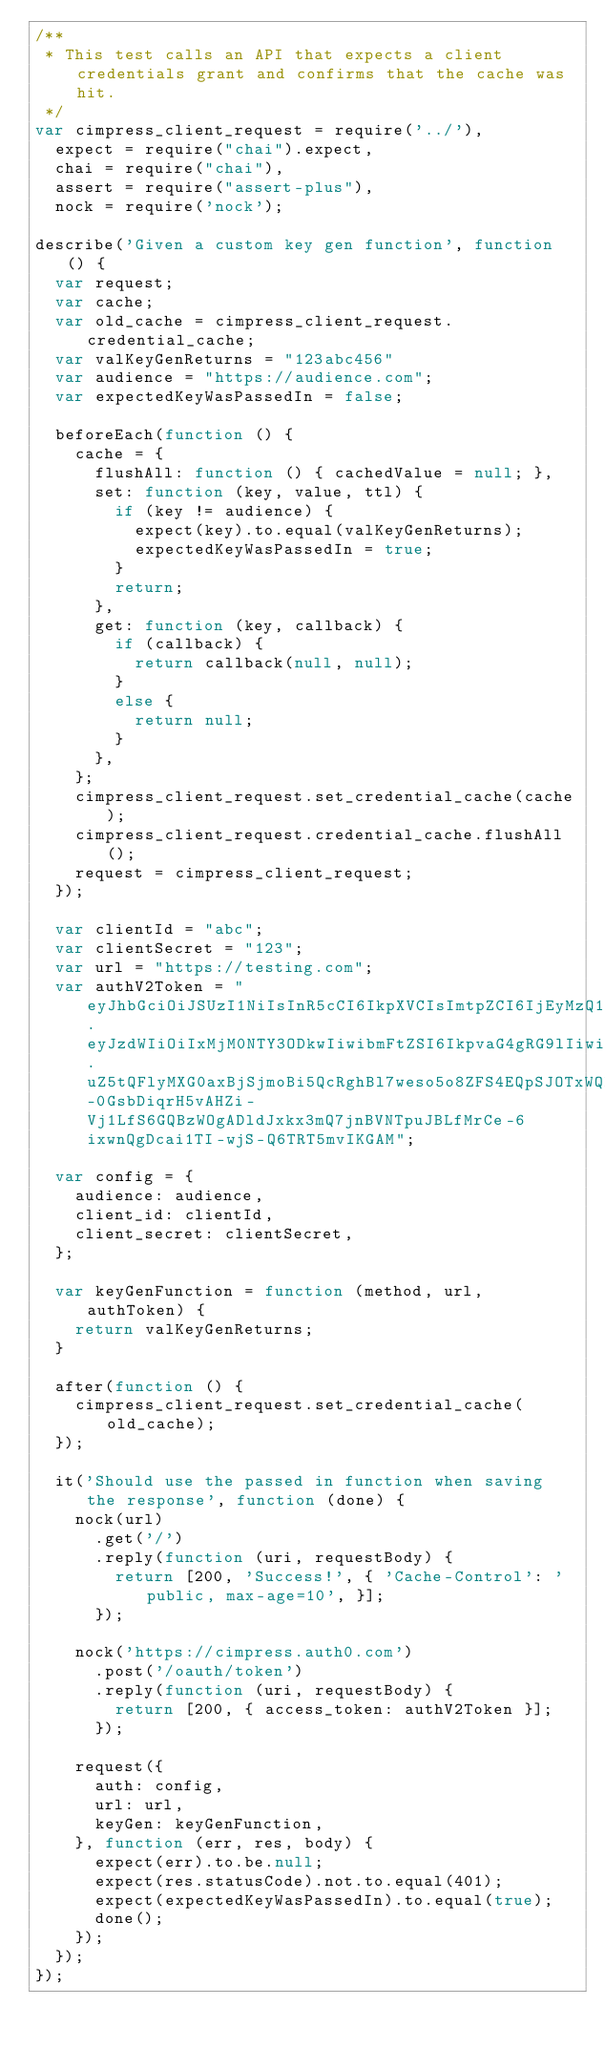Convert code to text. <code><loc_0><loc_0><loc_500><loc_500><_JavaScript_>/**
 * This test calls an API that expects a client credentials grant and confirms that the cache was hit.
 */
var cimpress_client_request = require('../'),
  expect = require("chai").expect,
  chai = require("chai"),
  assert = require("assert-plus"),
  nock = require('nock');

describe('Given a custom key gen function', function () {
  var request;
  var cache;
  var old_cache = cimpress_client_request.credential_cache;
  var valKeyGenReturns = "123abc456"
  var audience = "https://audience.com";
  var expectedKeyWasPassedIn = false;

  beforeEach(function () {
    cache = {
      flushAll: function () { cachedValue = null; },
      set: function (key, value, ttl) {
        if (key != audience) {
          expect(key).to.equal(valKeyGenReturns);
          expectedKeyWasPassedIn = true;
        }
        return;
      },
      get: function (key, callback) {
        if (callback) {
          return callback(null, null);
        }
        else {
          return null;
        }
      },
    };
    cimpress_client_request.set_credential_cache(cache);
    cimpress_client_request.credential_cache.flushAll();
    request = cimpress_client_request;
  });

  var clientId = "abc";
  var clientSecret = "123";
  var url = "https://testing.com";
  var authV2Token = "eyJhbGciOiJSUzI1NiIsInR5cCI6IkpXVCIsImtpZCI6IjEyMzQ1Njc4OSJ9.eyJzdWIiOiIxMjM0NTY3ODkwIiwibmFtZSI6IkpvaG4gRG9lIiwiYWRtaW4iOnRydWV9.uZ5tQFlyMXG0axBjSjmoBi5QcRghBl7weso5o8ZFS4EQpSJOTxWQHMCkI_2oeJo_XXdNdAZR2jXZth_-0GsbDiqrH5vAHZi-Vj1LfS6GQBzWOgADldJxkx3mQ7jnBVNTpuJBLfMrCe-6ixwnQgDcai1TI-wjS-Q6TRT5mvIKGAM";

  var config = {
    audience: audience,
    client_id: clientId,
    client_secret: clientSecret,
  };

  var keyGenFunction = function (method, url, authToken) {
    return valKeyGenReturns;
  }

  after(function () {
    cimpress_client_request.set_credential_cache(old_cache);
  });

  it('Should use the passed in function when saving the response', function (done) {
    nock(url)
      .get('/')
      .reply(function (uri, requestBody) {
        return [200, 'Success!', { 'Cache-Control': 'public, max-age=10', }];
      });

    nock('https://cimpress.auth0.com')
      .post('/oauth/token')
      .reply(function (uri, requestBody) {
        return [200, { access_token: authV2Token }];
      });

    request({
      auth: config,
      url: url,
      keyGen: keyGenFunction,
    }, function (err, res, body) {
      expect(err).to.be.null;
      expect(res.statusCode).not.to.equal(401);
      expect(expectedKeyWasPassedIn).to.equal(true);
      done();
    });
  });
});
</code> 